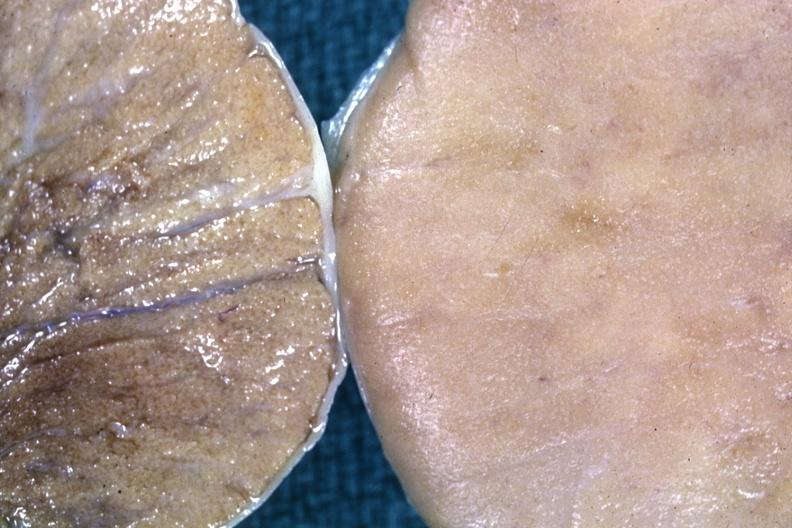what does this image show?
Answer the question using a single word or phrase. Fixed tissue contrast of normal cut surface with one having diffuse infiltrate 